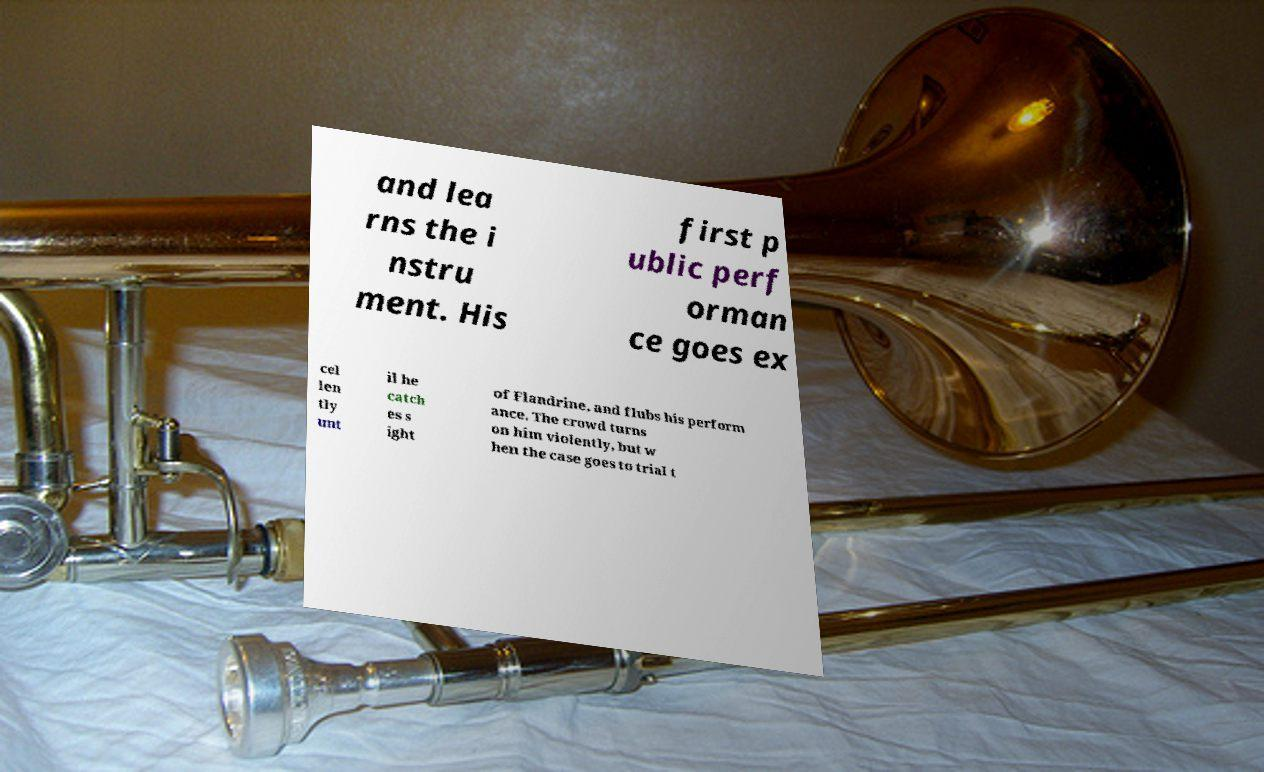Can you read and provide the text displayed in the image?This photo seems to have some interesting text. Can you extract and type it out for me? and lea rns the i nstru ment. His first p ublic perf orman ce goes ex cel len tly unt il he catch es s ight of Flandrine, and flubs his perform ance. The crowd turns on him violently, but w hen the case goes to trial t 